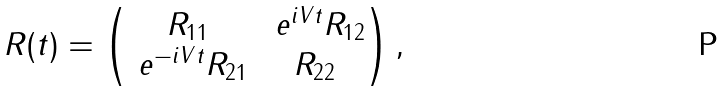Convert formula to latex. <formula><loc_0><loc_0><loc_500><loc_500>R ( t ) = \begin{pmatrix} R _ { 1 1 } & \ e ^ { i V t } R _ { 1 2 } \\ \ e ^ { - i V t } R _ { 2 1 } & R _ { 2 2 } \end{pmatrix} ,</formula> 